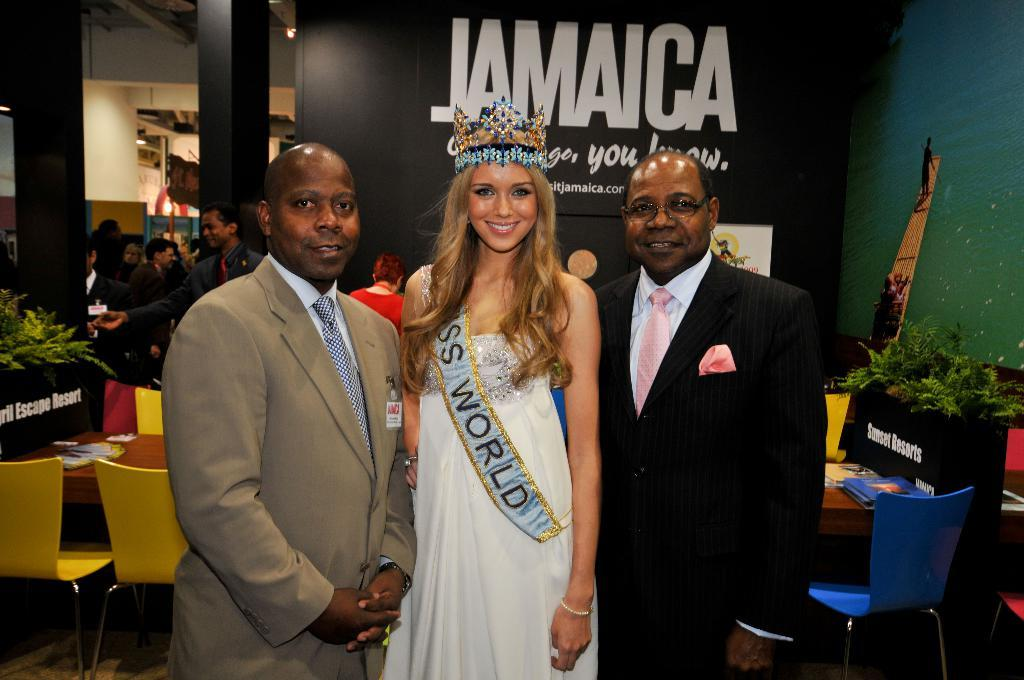How many people are present in the image? There are persons in the image, but the exact number cannot be determined from the provided facts. What can be seen in the background of the image? In the background of the image, there are plants, boards, a wall, chairs, a table, and other objects. Can you describe the setting of the image? The image appears to be set in a room or outdoor area with various objects and structures in the background. What type of camera is being used to take the scene in the image? There is no information about a camera being used to take the scene in the image. The image itself is a static representation and does not require a camera for its existence. 